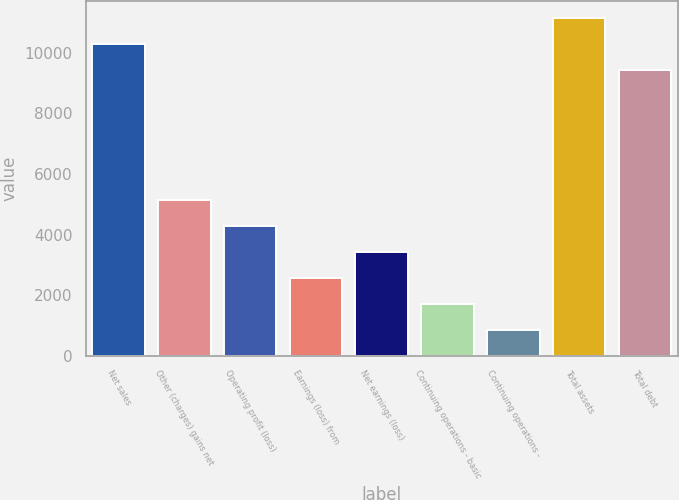<chart> <loc_0><loc_0><loc_500><loc_500><bar_chart><fcel>Net sales<fcel>Other (charges) gains net<fcel>Operating profit (loss)<fcel>Earnings (loss) from<fcel>Net earnings (loss)<fcel>Continuing operations - basic<fcel>Continuing operations -<fcel>Total assets<fcel>Total debt<nl><fcel>10303<fcel>5152.08<fcel>4293.59<fcel>2576.61<fcel>3435.1<fcel>1718.12<fcel>859.64<fcel>11161.5<fcel>9444.52<nl></chart> 